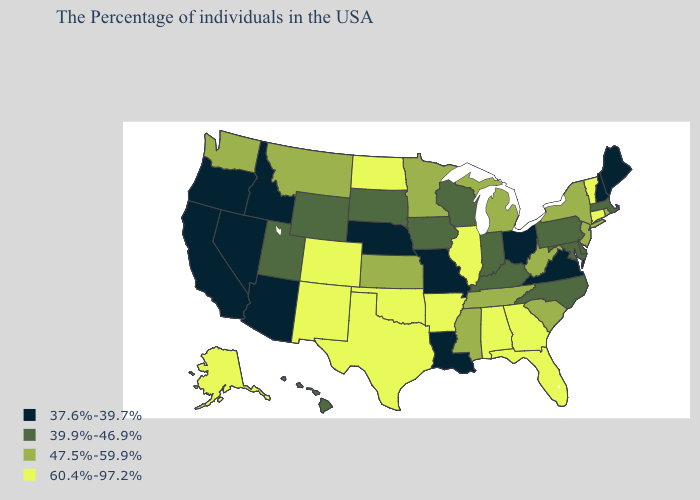What is the highest value in the USA?
Quick response, please. 60.4%-97.2%. Name the states that have a value in the range 47.5%-59.9%?
Keep it brief. Rhode Island, New York, New Jersey, South Carolina, West Virginia, Michigan, Tennessee, Mississippi, Minnesota, Kansas, Montana, Washington. Name the states that have a value in the range 37.6%-39.7%?
Short answer required. Maine, New Hampshire, Virginia, Ohio, Louisiana, Missouri, Nebraska, Arizona, Idaho, Nevada, California, Oregon. What is the value of Arkansas?
Give a very brief answer. 60.4%-97.2%. What is the value of Mississippi?
Concise answer only. 47.5%-59.9%. What is the value of Rhode Island?
Short answer required. 47.5%-59.9%. What is the highest value in the West ?
Short answer required. 60.4%-97.2%. Among the states that border Kentucky , which have the highest value?
Be succinct. Illinois. Name the states that have a value in the range 39.9%-46.9%?
Answer briefly. Massachusetts, Delaware, Maryland, Pennsylvania, North Carolina, Kentucky, Indiana, Wisconsin, Iowa, South Dakota, Wyoming, Utah, Hawaii. Does Alaska have the highest value in the USA?
Be succinct. Yes. Which states have the highest value in the USA?
Quick response, please. Vermont, Connecticut, Florida, Georgia, Alabama, Illinois, Arkansas, Oklahoma, Texas, North Dakota, Colorado, New Mexico, Alaska. Is the legend a continuous bar?
Concise answer only. No. What is the lowest value in states that border Iowa?
Keep it brief. 37.6%-39.7%. What is the value of West Virginia?
Short answer required. 47.5%-59.9%. What is the value of Georgia?
Concise answer only. 60.4%-97.2%. 